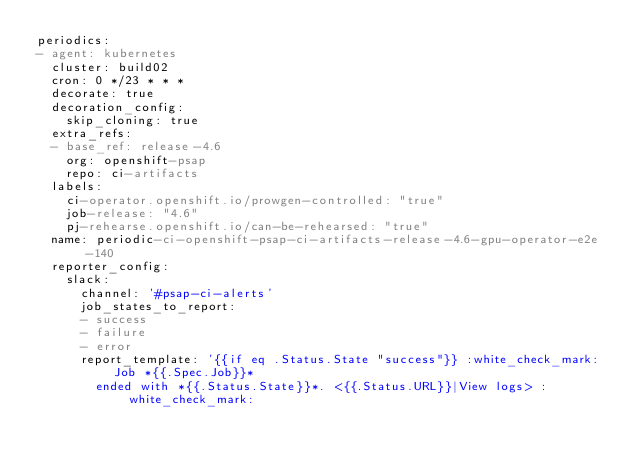Convert code to text. <code><loc_0><loc_0><loc_500><loc_500><_YAML_>periodics:
- agent: kubernetes
  cluster: build02
  cron: 0 */23 * * *
  decorate: true
  decoration_config:
    skip_cloning: true
  extra_refs:
  - base_ref: release-4.6
    org: openshift-psap
    repo: ci-artifacts
  labels:
    ci-operator.openshift.io/prowgen-controlled: "true"
    job-release: "4.6"
    pj-rehearse.openshift.io/can-be-rehearsed: "true"
  name: periodic-ci-openshift-psap-ci-artifacts-release-4.6-gpu-operator-e2e-140
  reporter_config:
    slack:
      channel: '#psap-ci-alerts'
      job_states_to_report:
      - success
      - failure
      - error
      report_template: '{{if eq .Status.State "success"}} :white_check_mark: Job *{{.Spec.Job}}*
        ended with *{{.Status.State}}*. <{{.Status.URL}}|View logs> :white_check_mark:</code> 